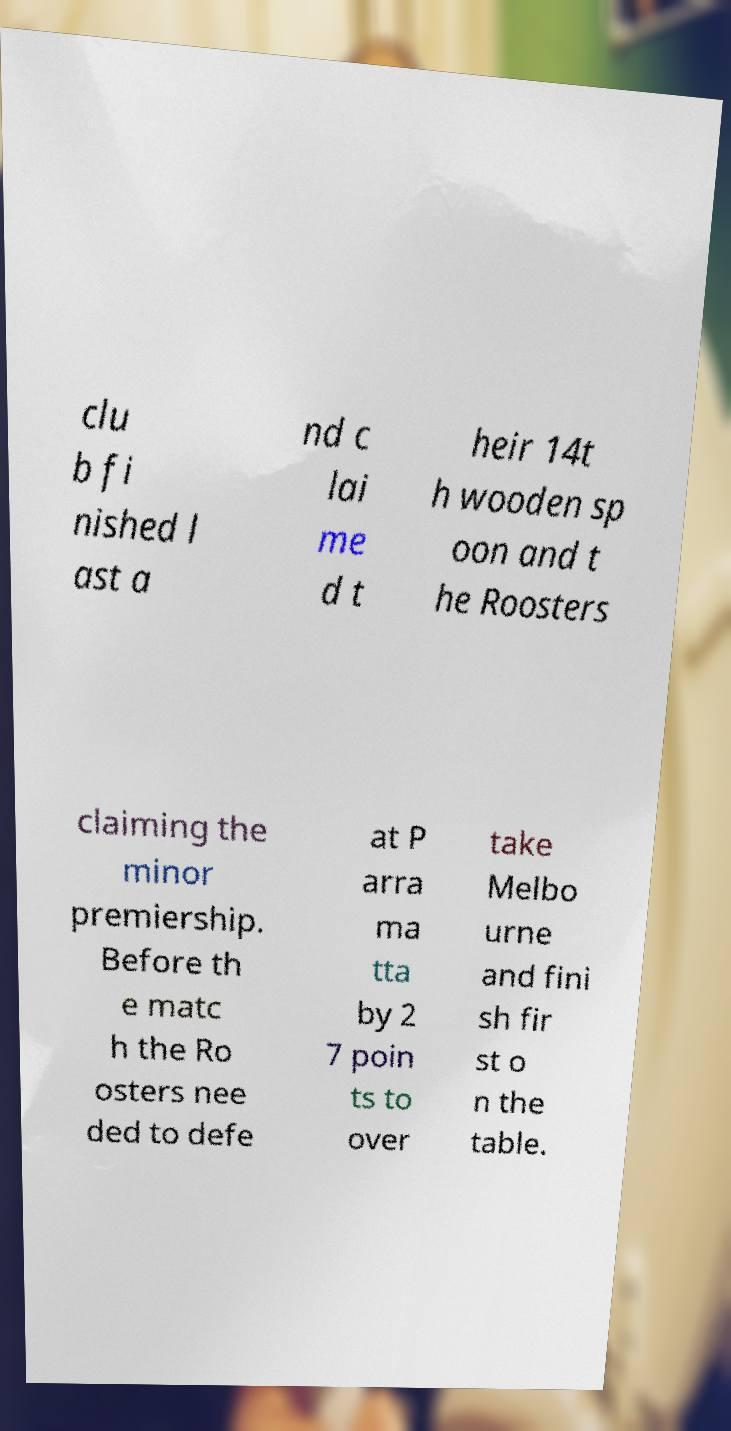Please identify and transcribe the text found in this image. clu b fi nished l ast a nd c lai me d t heir 14t h wooden sp oon and t he Roosters claiming the minor premiership. Before th e matc h the Ro osters nee ded to defe at P arra ma tta by 2 7 poin ts to over take Melbo urne and fini sh fir st o n the table. 